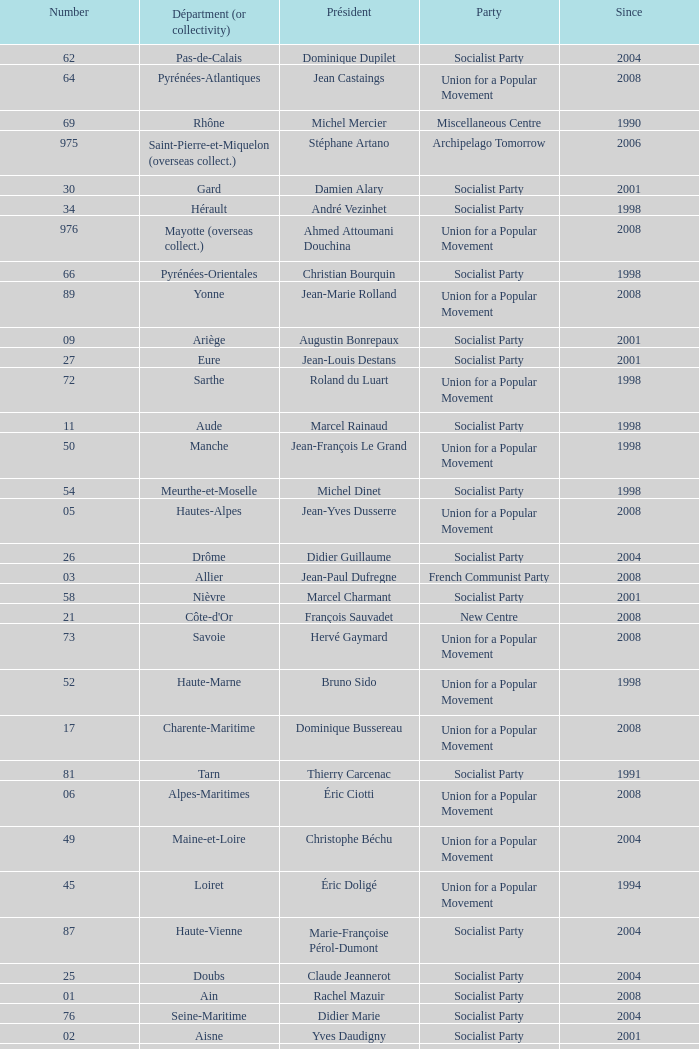Parse the table in full. {'header': ['Number', 'Départment (or collectivity)', 'Président', 'Party', 'Since'], 'rows': [['62', 'Pas-de-Calais', 'Dominique Dupilet', 'Socialist Party', '2004'], ['64', 'Pyrénées-Atlantiques', 'Jean Castaings', 'Union for a Popular Movement', '2008'], ['69', 'Rhône', 'Michel Mercier', 'Miscellaneous Centre', '1990'], ['975', 'Saint-Pierre-et-Miquelon (overseas collect.)', 'Stéphane Artano', 'Archipelago Tomorrow', '2006'], ['30', 'Gard', 'Damien Alary', 'Socialist Party', '2001'], ['34', 'Hérault', 'André Vezinhet', 'Socialist Party', '1998'], ['976', 'Mayotte (overseas collect.)', 'Ahmed Attoumani Douchina', 'Union for a Popular Movement', '2008'], ['66', 'Pyrénées-Orientales', 'Christian Bourquin', 'Socialist Party', '1998'], ['89', 'Yonne', 'Jean-Marie Rolland', 'Union for a Popular Movement', '2008'], ['09', 'Ariège', 'Augustin Bonrepaux', 'Socialist Party', '2001'], ['27', 'Eure', 'Jean-Louis Destans', 'Socialist Party', '2001'], ['72', 'Sarthe', 'Roland du Luart', 'Union for a Popular Movement', '1998'], ['11', 'Aude', 'Marcel Rainaud', 'Socialist Party', '1998'], ['50', 'Manche', 'Jean-François Le Grand', 'Union for a Popular Movement', '1998'], ['54', 'Meurthe-et-Moselle', 'Michel Dinet', 'Socialist Party', '1998'], ['05', 'Hautes-Alpes', 'Jean-Yves Dusserre', 'Union for a Popular Movement', '2008'], ['26', 'Drôme', 'Didier Guillaume', 'Socialist Party', '2004'], ['03', 'Allier', 'Jean-Paul Dufregne', 'French Communist Party', '2008'], ['58', 'Nièvre', 'Marcel Charmant', 'Socialist Party', '2001'], ['21', "Côte-d'Or", 'François Sauvadet', 'New Centre', '2008'], ['73', 'Savoie', 'Hervé Gaymard', 'Union for a Popular Movement', '2008'], ['52', 'Haute-Marne', 'Bruno Sido', 'Union for a Popular Movement', '1998'], ['17', 'Charente-Maritime', 'Dominique Bussereau', 'Union for a Popular Movement', '2008'], ['81', 'Tarn', 'Thierry Carcenac', 'Socialist Party', '1991'], ['06', 'Alpes-Maritimes', 'Éric Ciotti', 'Union for a Popular Movement', '2008'], ['49', 'Maine-et-Loire', 'Christophe Béchu', 'Union for a Popular Movement', '2004'], ['45', 'Loiret', 'Éric Doligé', 'Union for a Popular Movement', '1994'], ['87', 'Haute-Vienne', 'Marie-Françoise Pérol-Dumont', 'Socialist Party', '2004'], ['25', 'Doubs', 'Claude Jeannerot', 'Socialist Party', '2004'], ['01', 'Ain', 'Rachel Mazuir', 'Socialist Party', '2008'], ['76', 'Seine-Maritime', 'Didier Marie', 'Socialist Party', '2004'], ['02', 'Aisne', 'Yves Daudigny', 'Socialist Party', '2001'], ['57', 'Moselle', 'Philippe Leroy', 'Union for a Popular Movement', '1992'], ['38', 'Isère', 'André Vallini', 'Socialist Party', '2001'], ['55', 'Meuse', 'Christian Namy', 'Miscellaneous Right', '2004'], ['53', 'Mayenne', 'Jean Arthuis', 'Miscellaneous Centre', '1992'], ['61', 'Orne', 'Alain Lambert', 'Union for a Popular Movement', '2007'], ['80', 'Somme', 'Christian Manable', 'Socialist Party', '2008'], ['44', 'Loire-Atlantique', 'Patrick Mareschal', 'Socialist Party', '2004'], ['90', 'Territoire de Belfort', 'Yves Ackermann', 'Socialist Party', '2004'], ['84', 'Vaucluse', 'Claude Haut', 'Socialist Party', '2001'], ['92', 'Hauts-de-Seine', 'Patrick Devedjian', 'Union for a Popular Movement', '2007'], ['974', 'Réunion', 'Nassimah Dindar', 'Union for a Popular Movement', '2004'], ['972', 'Martinique', 'Claude Lise', 'Martinican Democratic Rally', '1992'], ['75', 'Paris', 'Bertrand Delanoë', 'Socialist Party', '2001'], ['13', 'Bouches-du-Rhône', 'Jean-Noël Guérini', 'Socialist Party', '1998'], ['39', 'Jura', 'Jean Raquin', 'Miscellaneous Right', '2008'], ['36', 'Indre', 'Louis Pinton', 'Union for a Popular Movement', '1998'], ['93', 'Seine-Saint-Denis', 'Claude Bartolone', 'Socialist Party', '2008'], ['41', 'Loir-et-Cher', 'Maurice Leroy', 'New Centre', '2004'], ['88', 'Vosges', 'Christian Poncelet', 'Union for a Popular Movement', '1976'], ['85', 'Vendée', 'Philippe de Villiers', 'Movement for France', '1988'], ['56', 'Morbihan', 'Joseph-François Kerguéris', 'Democratic Movement', '2004'], ['70', 'Haute-Saône', 'Yves Krattinger', 'Socialist Party', '2002'], ['47', 'Lot-et-Garonne', 'Pierre Camani', 'Socialist Party', '2008'], ['63', 'Puy-de-Dôme', 'Jean-Yves Gouttebel', 'Socialist Party', '2004'], ['43', 'Haute-Loire', 'Gérard Roche', 'Union for a Popular Movement', '2004'], ['2B', 'Haute-Corse', 'Joseph Castelli', 'Left Radical Party', '2010'], ['94', 'Val-de-Marne', 'Christian Favier', 'French Communist Party', '2001'], ['24', 'Dordogne', 'Bernard Cazeau', 'Socialist Party', '1994'], ['12', 'Aveyron', 'Jean-Claude Luche', 'Union for a Popular Movement', '2008'], ['10', 'Aube', 'Philippe Adnot', 'Liberal and Moderate Movement', '1990'], ['77', 'Seine-et-Marne', 'Vincent Eblé', 'Socialist Party', '2004'], ['31', 'Haute-Garonne', 'Pierre Izard', 'Socialist Party', '1988'], ['74', 'Haute-Savoie', 'Christian Monteil', 'Miscellaneous Right', '2008'], ['33', 'Gironde', 'Philippe Madrelle', 'Socialist Party', '1988'], ['37', 'Indre-et-Loire', 'Claude Roiron', 'Socialist Party', '2008'], ['91', 'Essonne', 'Michel Berson', 'Socialist Party', '1998'], ['51', 'Marne', 'René-Paul Savary', 'Union for a Popular Movement', '2003'], ['07', 'Ardèche', 'Pascal Terrasse', 'Socialist Party', '2006'], ['23', 'Creuse', 'Jean-Jacques Lozach', 'Socialist Party', '2001'], ['14', 'Calvados', "Anne d'Ornano", 'Miscellaneous Right', '1991'], ['86', 'Vienne', 'Claude Bertaud', 'Union for a Popular Movement', '2008'], ['83', 'Var', 'Horace Lanfranchi', 'Union for a Popular Movement', '2002'], ['78', 'Yvelines', 'Pierre Bédier', 'Union for a Popular Movement', '2005'], ['29', 'Finistère', 'Pierre Maille', 'Socialist Party', '1998'], ['08', 'Ardennes', 'Benoît Huré', 'Union for a Popular Movement', '2004'], ['28', 'Eure-et-Loir', 'Albéric de Montgolfier', 'Union for a Popular Movement', '2001'], ['42', 'Loire', 'Bernard Bonne', 'Union for a Popular Movement', '2008'], ['971', 'Guadeloupe', 'Jacques Gillot', 'United Guadeloupe, Socialism and Realities', '2001'], ['95', 'Val-d’Oise', 'Arnaud Bazin', 'Union for a Popular Movement', '2011'], ['60', 'Oise', 'Yves Rome', 'Socialist Party', '2004'], ['16', 'Charente', 'Michel Boutant', 'Socialist Party', '2004'], ['04', 'Alpes-de-Haute-Provence', 'Jean-Louis Bianco', 'Socialist Party', '1998'], ['19', 'Corrèze', 'François Hollande', 'Socialist Party', '2008'], ['65', 'Hautes-Pyrénées', 'Josette Durrieu', 'Socialist Party', '2008'], ['18', 'Cher', 'Alain Rafesthain', 'Socialist Party', '2004'], ['82', 'Tarn-et-Garonne', 'Jean-Michel Baylet', 'Left Radical Party', '1986'], ['48', 'Lozère', 'Jean-Paul Pourquier', 'Union for a Popular Movement', '2004'], ['35', 'Ille-et-Vilaine', 'Jean-Louis Tourenne', 'Socialist Party', '2004'], ['59', 'Nord', 'Patrick Kanner', 'Socialist Party', '1998'], ['2A', 'Corse-du-Sud', 'Jean-Jacques Panunzi', 'Union for a Popular Movement', '2006'], ['973', 'Guyane', 'Alain Tien-Liong', 'Miscellaneous Left', '2008'], ['22', "Côtes-d'Armor", 'Claudy Lebreton', 'Socialist Party', '1997'], ['71', 'Saône-et-Loire', 'Arnaud Montebourg', 'Socialist Party', '2008'], ['79', 'Deux-Sèvres', 'Éric Gautier', 'Socialist Party', '2008'], ['32', 'Gers', 'Philippe Martin', 'Socialist Party', '1998'], ['15', 'Cantal', 'Vincent Descœur', 'Union for a Popular Movement', '2001'], ['67', 'Bas-Rhin', 'Guy-Dominique Kennel', 'Union for a Popular Movement', '2008'], ['68', 'Haut-Rhin', 'Charles Buttner', 'Union for a Popular Movement', '2004'], ['40', 'Landes', 'Henri Emmanuelli', 'Socialist Party', '1982'], ['46', 'Lot', 'Gérard Miquel', 'Socialist Party', '2004']]} Who is the president from the Union for a Popular Movement party that represents the Hautes-Alpes department? Jean-Yves Dusserre. 